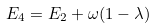Convert formula to latex. <formula><loc_0><loc_0><loc_500><loc_500>E _ { 4 } = E _ { 2 } + \omega ( 1 - \lambda )</formula> 